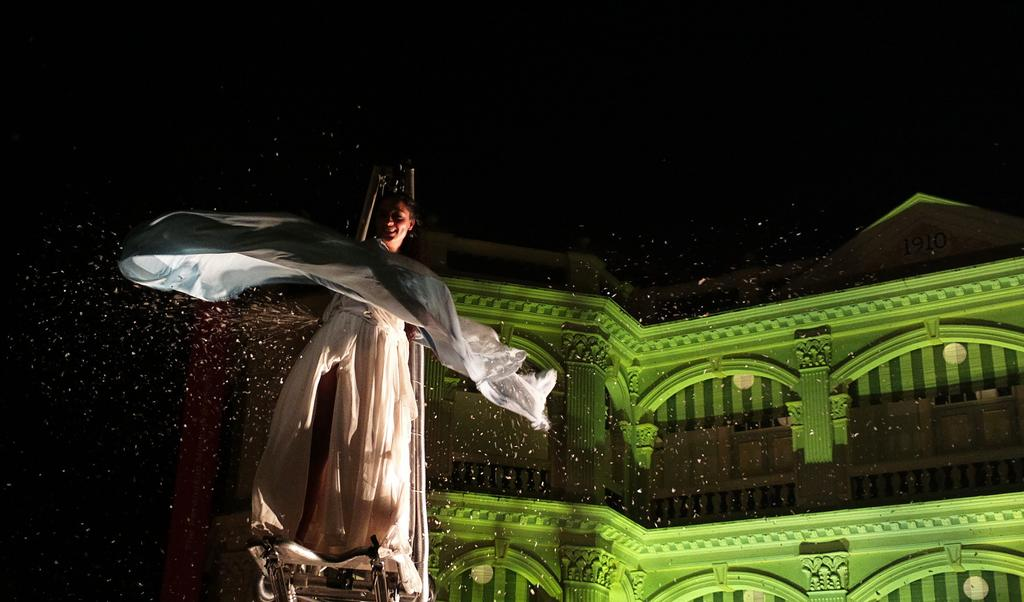What is the main subject in the image? There is a person in the image. What else can be seen in the image besides the person? There is an object in the image. What can be seen in the distance behind the person and object? There is a building in the background of the image. What is the color of the background in the image? The background of the image is black. What type of winter sport is the person participating in the image? There is no indication of a winter sport or any sports activity in the image. 